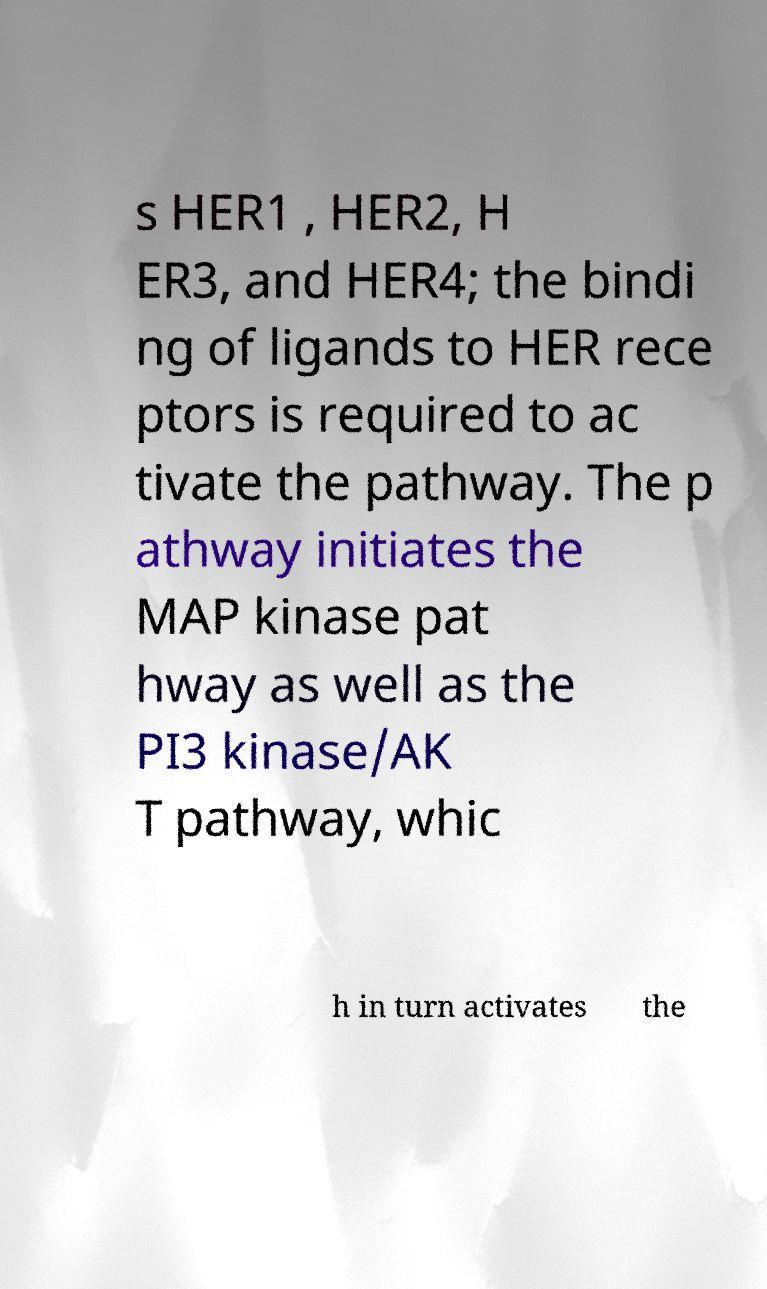I need the written content from this picture converted into text. Can you do that? s HER1 , HER2, H ER3, and HER4; the bindi ng of ligands to HER rece ptors is required to ac tivate the pathway. The p athway initiates the MAP kinase pat hway as well as the PI3 kinase/AK T pathway, whic h in turn activates the 